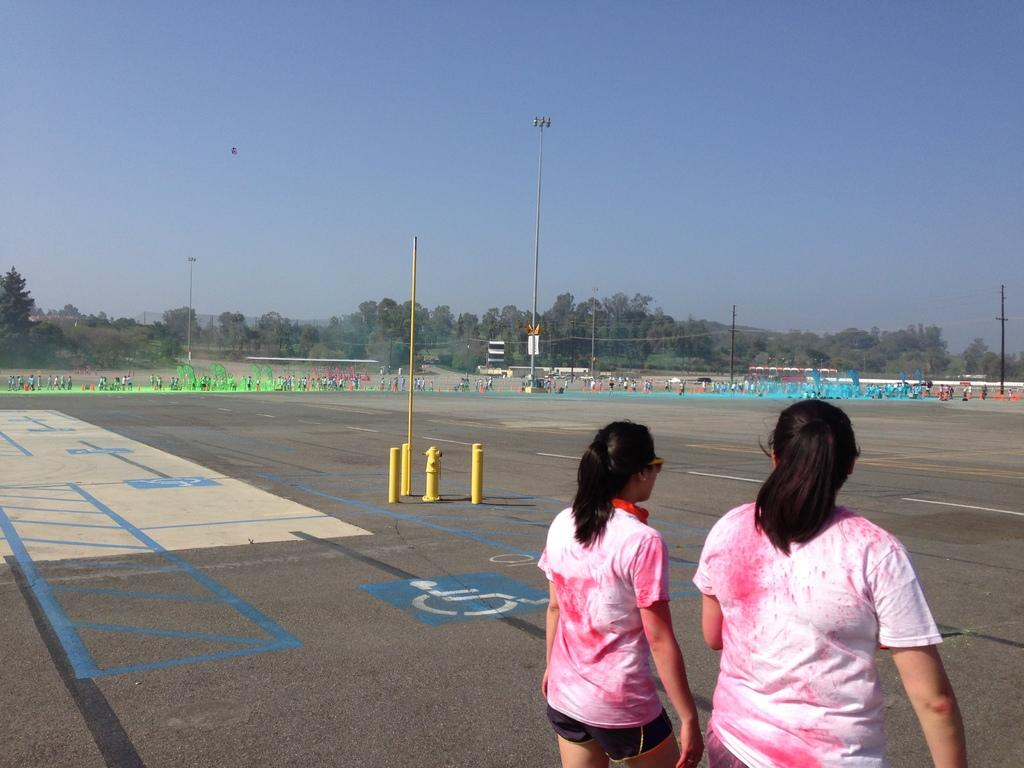How many people are present in the image? There are 2 people standing in the image. What objects can be seen in the image besides the people? There are poles, wires, and trees in the image. What is visible at the top of the image? The sky is visible at the top of the image. What is the reason for the wires being present in the image? The reason for the wires being present in the image is not mentioned in the facts provided. How do the acoustics of the area affect the people in the image? There is no information about the acoustics of the area in the image, so we cannot determine how it affects the people. 